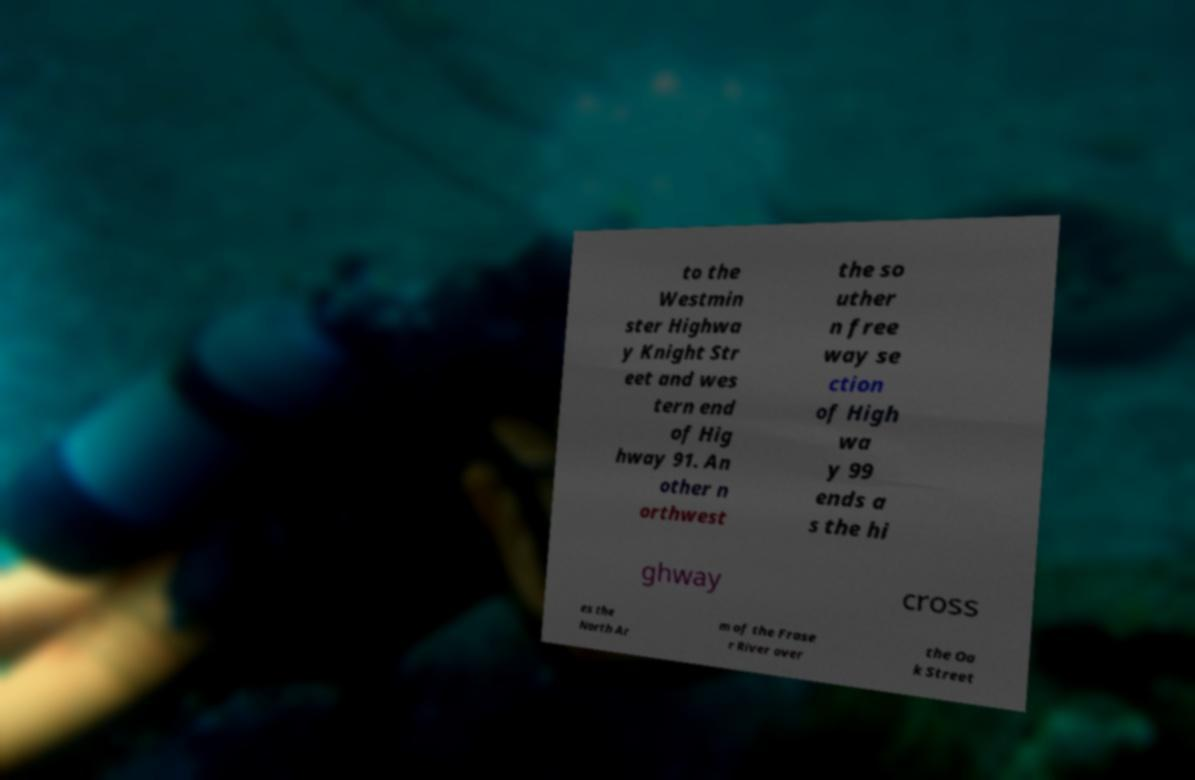Please identify and transcribe the text found in this image. to the Westmin ster Highwa y Knight Str eet and wes tern end of Hig hway 91. An other n orthwest the so uther n free way se ction of High wa y 99 ends a s the hi ghway cross es the North Ar m of the Frase r River over the Oa k Street 